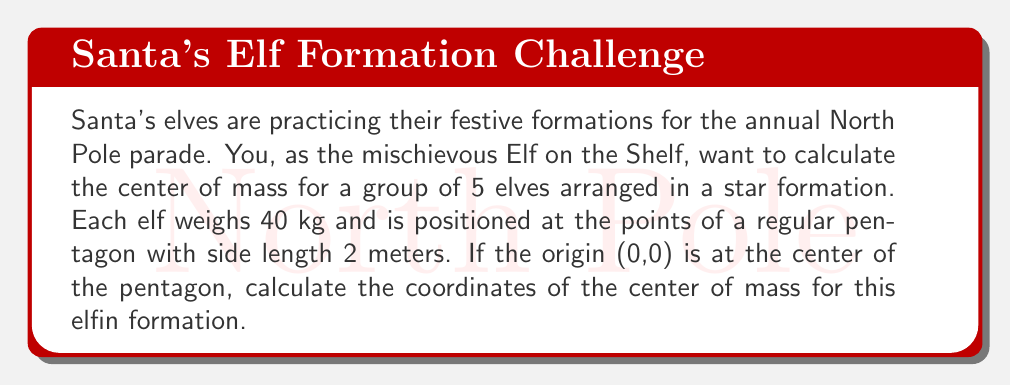Help me with this question. Let's approach this step-by-step:

1) First, we need to determine the coordinates of each elf. In a regular pentagon centered at the origin, the coordinates of the vertices can be expressed as:

   $$(x_k, y_k) = (r \cos(\frac{2\pi k}{5}), r \sin(\frac{2\pi k}{5}))$$

   where $r$ is the radius of the circumscribed circle and $k = 0, 1, 2, 3, 4$.

2) The radius $r$ can be calculated using the side length $s$ of the pentagon:

   $$r = \frac{s}{2 \sin(\frac{\pi}{5})} = \frac{2}{2 \sin(\frac{\pi}{5})} \approx 1.7013$$

3) Now, let's calculate the coordinates for each elf:

   Elf 1: $(1.7013, 0)$
   Elf 2: $(0.5257, 1.6181)$
   Elf 3: $(-1.3777, 1.0000)$
   Elf 4: $(-1.3777, -1.0000)$
   Elf 5: $(0.5257, -1.6181)$

4) The center of mass formula for a system of particles is:

   $$\vec{r}_{cm} = \frac{\sum_{i=1}^n m_i \vec{r}_i}{\sum_{i=1}^n m_i}$$

   where $m_i$ is the mass of each particle and $\vec{r}_i$ is its position vector.

5) Since all elves have the same mass (40 kg), we can simplify this to:

   $$\vec{r}_{cm} = \frac{1}{5} \sum_{i=1}^5 \vec{r}_i$$

6) Summing up the x and y coordinates separately:

   $$x_{cm} = \frac{1}{5}(1.7013 + 0.5257 - 1.3777 - 1.3777 + 0.5257) = 0$$
   $$y_{cm} = \frac{1}{5}(0 + 1.6181 + 1.0000 - 1.0000 - 1.6181) = 0$$

7) Therefore, the center of mass is at (0, 0), which is the center of the pentagon.
Answer: $(0, 0)$ 